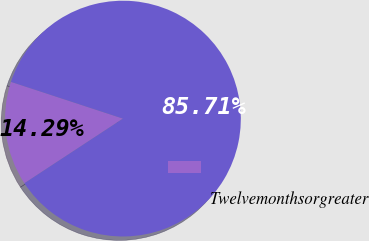Convert chart to OTSL. <chart><loc_0><loc_0><loc_500><loc_500><pie_chart><ecel><fcel>Twelvemonthsorgreater<nl><fcel>14.29%<fcel>85.71%<nl></chart> 